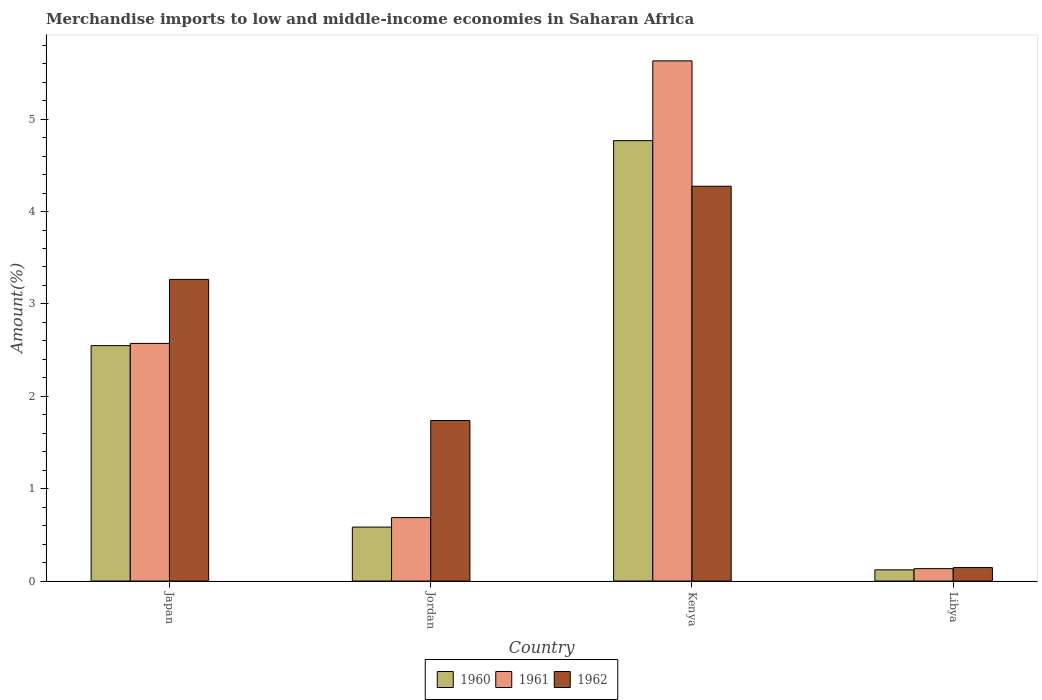How many different coloured bars are there?
Provide a short and direct response. 3. Are the number of bars per tick equal to the number of legend labels?
Provide a short and direct response. Yes. Are the number of bars on each tick of the X-axis equal?
Offer a terse response. Yes. How many bars are there on the 2nd tick from the left?
Keep it short and to the point. 3. How many bars are there on the 3rd tick from the right?
Offer a very short reply. 3. What is the label of the 1st group of bars from the left?
Your answer should be compact. Japan. In how many cases, is the number of bars for a given country not equal to the number of legend labels?
Your response must be concise. 0. What is the percentage of amount earned from merchandise imports in 1962 in Kenya?
Your answer should be very brief. 4.27. Across all countries, what is the maximum percentage of amount earned from merchandise imports in 1960?
Give a very brief answer. 4.77. Across all countries, what is the minimum percentage of amount earned from merchandise imports in 1960?
Offer a very short reply. 0.12. In which country was the percentage of amount earned from merchandise imports in 1962 maximum?
Keep it short and to the point. Kenya. In which country was the percentage of amount earned from merchandise imports in 1961 minimum?
Offer a very short reply. Libya. What is the total percentage of amount earned from merchandise imports in 1961 in the graph?
Your response must be concise. 9.02. What is the difference between the percentage of amount earned from merchandise imports in 1960 in Jordan and that in Kenya?
Ensure brevity in your answer.  -4.18. What is the difference between the percentage of amount earned from merchandise imports in 1962 in Libya and the percentage of amount earned from merchandise imports in 1961 in Kenya?
Ensure brevity in your answer.  -5.48. What is the average percentage of amount earned from merchandise imports in 1962 per country?
Your response must be concise. 2.36. What is the difference between the percentage of amount earned from merchandise imports of/in 1960 and percentage of amount earned from merchandise imports of/in 1962 in Libya?
Ensure brevity in your answer.  -0.02. What is the ratio of the percentage of amount earned from merchandise imports in 1962 in Jordan to that in Libya?
Give a very brief answer. 11.91. Is the percentage of amount earned from merchandise imports in 1962 in Jordan less than that in Kenya?
Provide a succinct answer. Yes. Is the difference between the percentage of amount earned from merchandise imports in 1960 in Japan and Libya greater than the difference between the percentage of amount earned from merchandise imports in 1962 in Japan and Libya?
Offer a terse response. No. What is the difference between the highest and the second highest percentage of amount earned from merchandise imports in 1961?
Provide a short and direct response. -1.89. What is the difference between the highest and the lowest percentage of amount earned from merchandise imports in 1962?
Keep it short and to the point. 4.13. In how many countries, is the percentage of amount earned from merchandise imports in 1962 greater than the average percentage of amount earned from merchandise imports in 1962 taken over all countries?
Your answer should be compact. 2. Is the sum of the percentage of amount earned from merchandise imports in 1961 in Japan and Jordan greater than the maximum percentage of amount earned from merchandise imports in 1962 across all countries?
Ensure brevity in your answer.  No. How many bars are there?
Provide a short and direct response. 12. Are all the bars in the graph horizontal?
Your answer should be very brief. No. How many countries are there in the graph?
Offer a very short reply. 4. What is the difference between two consecutive major ticks on the Y-axis?
Give a very brief answer. 1. Are the values on the major ticks of Y-axis written in scientific E-notation?
Ensure brevity in your answer.  No. Does the graph contain any zero values?
Provide a succinct answer. No. Does the graph contain grids?
Give a very brief answer. No. Where does the legend appear in the graph?
Provide a short and direct response. Bottom center. How are the legend labels stacked?
Ensure brevity in your answer.  Horizontal. What is the title of the graph?
Ensure brevity in your answer.  Merchandise imports to low and middle-income economies in Saharan Africa. Does "1993" appear as one of the legend labels in the graph?
Provide a succinct answer. No. What is the label or title of the Y-axis?
Provide a short and direct response. Amount(%). What is the Amount(%) in 1960 in Japan?
Provide a short and direct response. 2.55. What is the Amount(%) of 1961 in Japan?
Your answer should be very brief. 2.57. What is the Amount(%) in 1962 in Japan?
Provide a succinct answer. 3.27. What is the Amount(%) in 1960 in Jordan?
Your answer should be compact. 0.58. What is the Amount(%) in 1961 in Jordan?
Your response must be concise. 0.69. What is the Amount(%) in 1962 in Jordan?
Your response must be concise. 1.74. What is the Amount(%) in 1960 in Kenya?
Provide a short and direct response. 4.77. What is the Amount(%) of 1961 in Kenya?
Give a very brief answer. 5.63. What is the Amount(%) of 1962 in Kenya?
Keep it short and to the point. 4.27. What is the Amount(%) in 1960 in Libya?
Provide a succinct answer. 0.12. What is the Amount(%) in 1961 in Libya?
Your answer should be compact. 0.13. What is the Amount(%) in 1962 in Libya?
Keep it short and to the point. 0.15. Across all countries, what is the maximum Amount(%) in 1960?
Your answer should be very brief. 4.77. Across all countries, what is the maximum Amount(%) of 1961?
Make the answer very short. 5.63. Across all countries, what is the maximum Amount(%) of 1962?
Make the answer very short. 4.27. Across all countries, what is the minimum Amount(%) of 1960?
Ensure brevity in your answer.  0.12. Across all countries, what is the minimum Amount(%) of 1961?
Give a very brief answer. 0.13. Across all countries, what is the minimum Amount(%) of 1962?
Give a very brief answer. 0.15. What is the total Amount(%) of 1960 in the graph?
Ensure brevity in your answer.  8.02. What is the total Amount(%) in 1961 in the graph?
Your answer should be compact. 9.02. What is the total Amount(%) of 1962 in the graph?
Provide a succinct answer. 9.42. What is the difference between the Amount(%) in 1960 in Japan and that in Jordan?
Keep it short and to the point. 1.96. What is the difference between the Amount(%) in 1961 in Japan and that in Jordan?
Your answer should be compact. 1.89. What is the difference between the Amount(%) in 1962 in Japan and that in Jordan?
Your answer should be very brief. 1.53. What is the difference between the Amount(%) of 1960 in Japan and that in Kenya?
Ensure brevity in your answer.  -2.22. What is the difference between the Amount(%) in 1961 in Japan and that in Kenya?
Give a very brief answer. -3.06. What is the difference between the Amount(%) in 1962 in Japan and that in Kenya?
Offer a very short reply. -1.01. What is the difference between the Amount(%) in 1960 in Japan and that in Libya?
Keep it short and to the point. 2.43. What is the difference between the Amount(%) in 1961 in Japan and that in Libya?
Your response must be concise. 2.44. What is the difference between the Amount(%) of 1962 in Japan and that in Libya?
Your answer should be compact. 3.12. What is the difference between the Amount(%) of 1960 in Jordan and that in Kenya?
Provide a succinct answer. -4.18. What is the difference between the Amount(%) in 1961 in Jordan and that in Kenya?
Provide a succinct answer. -4.94. What is the difference between the Amount(%) of 1962 in Jordan and that in Kenya?
Make the answer very short. -2.54. What is the difference between the Amount(%) of 1960 in Jordan and that in Libya?
Give a very brief answer. 0.46. What is the difference between the Amount(%) of 1961 in Jordan and that in Libya?
Your answer should be very brief. 0.55. What is the difference between the Amount(%) of 1962 in Jordan and that in Libya?
Give a very brief answer. 1.59. What is the difference between the Amount(%) of 1960 in Kenya and that in Libya?
Offer a terse response. 4.65. What is the difference between the Amount(%) in 1961 in Kenya and that in Libya?
Keep it short and to the point. 5.5. What is the difference between the Amount(%) of 1962 in Kenya and that in Libya?
Your response must be concise. 4.13. What is the difference between the Amount(%) of 1960 in Japan and the Amount(%) of 1961 in Jordan?
Offer a very short reply. 1.86. What is the difference between the Amount(%) of 1960 in Japan and the Amount(%) of 1962 in Jordan?
Give a very brief answer. 0.81. What is the difference between the Amount(%) in 1961 in Japan and the Amount(%) in 1962 in Jordan?
Your response must be concise. 0.83. What is the difference between the Amount(%) of 1960 in Japan and the Amount(%) of 1961 in Kenya?
Your answer should be compact. -3.08. What is the difference between the Amount(%) in 1960 in Japan and the Amount(%) in 1962 in Kenya?
Keep it short and to the point. -1.73. What is the difference between the Amount(%) in 1961 in Japan and the Amount(%) in 1962 in Kenya?
Provide a short and direct response. -1.7. What is the difference between the Amount(%) in 1960 in Japan and the Amount(%) in 1961 in Libya?
Ensure brevity in your answer.  2.41. What is the difference between the Amount(%) in 1960 in Japan and the Amount(%) in 1962 in Libya?
Offer a very short reply. 2.4. What is the difference between the Amount(%) of 1961 in Japan and the Amount(%) of 1962 in Libya?
Ensure brevity in your answer.  2.43. What is the difference between the Amount(%) of 1960 in Jordan and the Amount(%) of 1961 in Kenya?
Keep it short and to the point. -5.05. What is the difference between the Amount(%) in 1960 in Jordan and the Amount(%) in 1962 in Kenya?
Give a very brief answer. -3.69. What is the difference between the Amount(%) in 1961 in Jordan and the Amount(%) in 1962 in Kenya?
Give a very brief answer. -3.59. What is the difference between the Amount(%) of 1960 in Jordan and the Amount(%) of 1961 in Libya?
Your response must be concise. 0.45. What is the difference between the Amount(%) of 1960 in Jordan and the Amount(%) of 1962 in Libya?
Your response must be concise. 0.44. What is the difference between the Amount(%) in 1961 in Jordan and the Amount(%) in 1962 in Libya?
Give a very brief answer. 0.54. What is the difference between the Amount(%) of 1960 in Kenya and the Amount(%) of 1961 in Libya?
Make the answer very short. 4.63. What is the difference between the Amount(%) of 1960 in Kenya and the Amount(%) of 1962 in Libya?
Your answer should be compact. 4.62. What is the difference between the Amount(%) in 1961 in Kenya and the Amount(%) in 1962 in Libya?
Keep it short and to the point. 5.49. What is the average Amount(%) in 1960 per country?
Provide a succinct answer. 2.01. What is the average Amount(%) of 1961 per country?
Make the answer very short. 2.26. What is the average Amount(%) in 1962 per country?
Offer a terse response. 2.36. What is the difference between the Amount(%) in 1960 and Amount(%) in 1961 in Japan?
Your response must be concise. -0.02. What is the difference between the Amount(%) in 1960 and Amount(%) in 1962 in Japan?
Your answer should be compact. -0.72. What is the difference between the Amount(%) in 1961 and Amount(%) in 1962 in Japan?
Give a very brief answer. -0.69. What is the difference between the Amount(%) in 1960 and Amount(%) in 1961 in Jordan?
Offer a very short reply. -0.1. What is the difference between the Amount(%) in 1960 and Amount(%) in 1962 in Jordan?
Ensure brevity in your answer.  -1.15. What is the difference between the Amount(%) in 1961 and Amount(%) in 1962 in Jordan?
Your answer should be very brief. -1.05. What is the difference between the Amount(%) of 1960 and Amount(%) of 1961 in Kenya?
Provide a short and direct response. -0.86. What is the difference between the Amount(%) in 1960 and Amount(%) in 1962 in Kenya?
Make the answer very short. 0.49. What is the difference between the Amount(%) in 1961 and Amount(%) in 1962 in Kenya?
Offer a terse response. 1.36. What is the difference between the Amount(%) of 1960 and Amount(%) of 1961 in Libya?
Your response must be concise. -0.01. What is the difference between the Amount(%) of 1960 and Amount(%) of 1962 in Libya?
Your answer should be very brief. -0.02. What is the difference between the Amount(%) of 1961 and Amount(%) of 1962 in Libya?
Keep it short and to the point. -0.01. What is the ratio of the Amount(%) of 1960 in Japan to that in Jordan?
Offer a terse response. 4.37. What is the ratio of the Amount(%) in 1961 in Japan to that in Jordan?
Your response must be concise. 3.75. What is the ratio of the Amount(%) in 1962 in Japan to that in Jordan?
Your response must be concise. 1.88. What is the ratio of the Amount(%) of 1960 in Japan to that in Kenya?
Ensure brevity in your answer.  0.53. What is the ratio of the Amount(%) of 1961 in Japan to that in Kenya?
Your answer should be compact. 0.46. What is the ratio of the Amount(%) in 1962 in Japan to that in Kenya?
Provide a succinct answer. 0.76. What is the ratio of the Amount(%) of 1960 in Japan to that in Libya?
Provide a short and direct response. 21.03. What is the ratio of the Amount(%) in 1961 in Japan to that in Libya?
Your answer should be compact. 19.19. What is the ratio of the Amount(%) of 1962 in Japan to that in Libya?
Ensure brevity in your answer.  22.38. What is the ratio of the Amount(%) of 1960 in Jordan to that in Kenya?
Your answer should be very brief. 0.12. What is the ratio of the Amount(%) of 1961 in Jordan to that in Kenya?
Offer a terse response. 0.12. What is the ratio of the Amount(%) in 1962 in Jordan to that in Kenya?
Your answer should be compact. 0.41. What is the ratio of the Amount(%) in 1960 in Jordan to that in Libya?
Provide a short and direct response. 4.82. What is the ratio of the Amount(%) in 1961 in Jordan to that in Libya?
Your response must be concise. 5.12. What is the ratio of the Amount(%) in 1962 in Jordan to that in Libya?
Keep it short and to the point. 11.91. What is the ratio of the Amount(%) of 1960 in Kenya to that in Libya?
Provide a short and direct response. 39.33. What is the ratio of the Amount(%) of 1961 in Kenya to that in Libya?
Make the answer very short. 42.01. What is the ratio of the Amount(%) in 1962 in Kenya to that in Libya?
Offer a terse response. 29.29. What is the difference between the highest and the second highest Amount(%) in 1960?
Your response must be concise. 2.22. What is the difference between the highest and the second highest Amount(%) in 1961?
Your answer should be very brief. 3.06. What is the difference between the highest and the second highest Amount(%) of 1962?
Ensure brevity in your answer.  1.01. What is the difference between the highest and the lowest Amount(%) in 1960?
Give a very brief answer. 4.65. What is the difference between the highest and the lowest Amount(%) in 1961?
Your answer should be compact. 5.5. What is the difference between the highest and the lowest Amount(%) of 1962?
Ensure brevity in your answer.  4.13. 